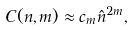Convert formula to latex. <formula><loc_0><loc_0><loc_500><loc_500>C ( n , m ) \approx c _ { m } \hat { n } ^ { 2 m } ,</formula> 